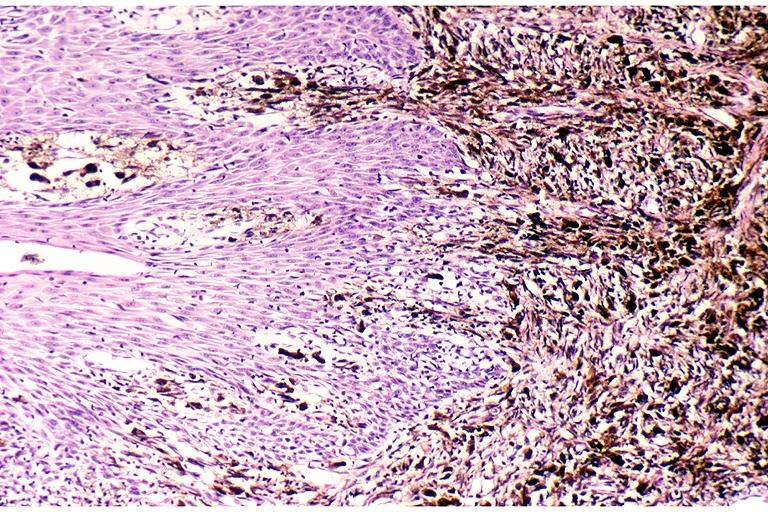what does this image show?
Answer the question using a single word or phrase. Melanoma 